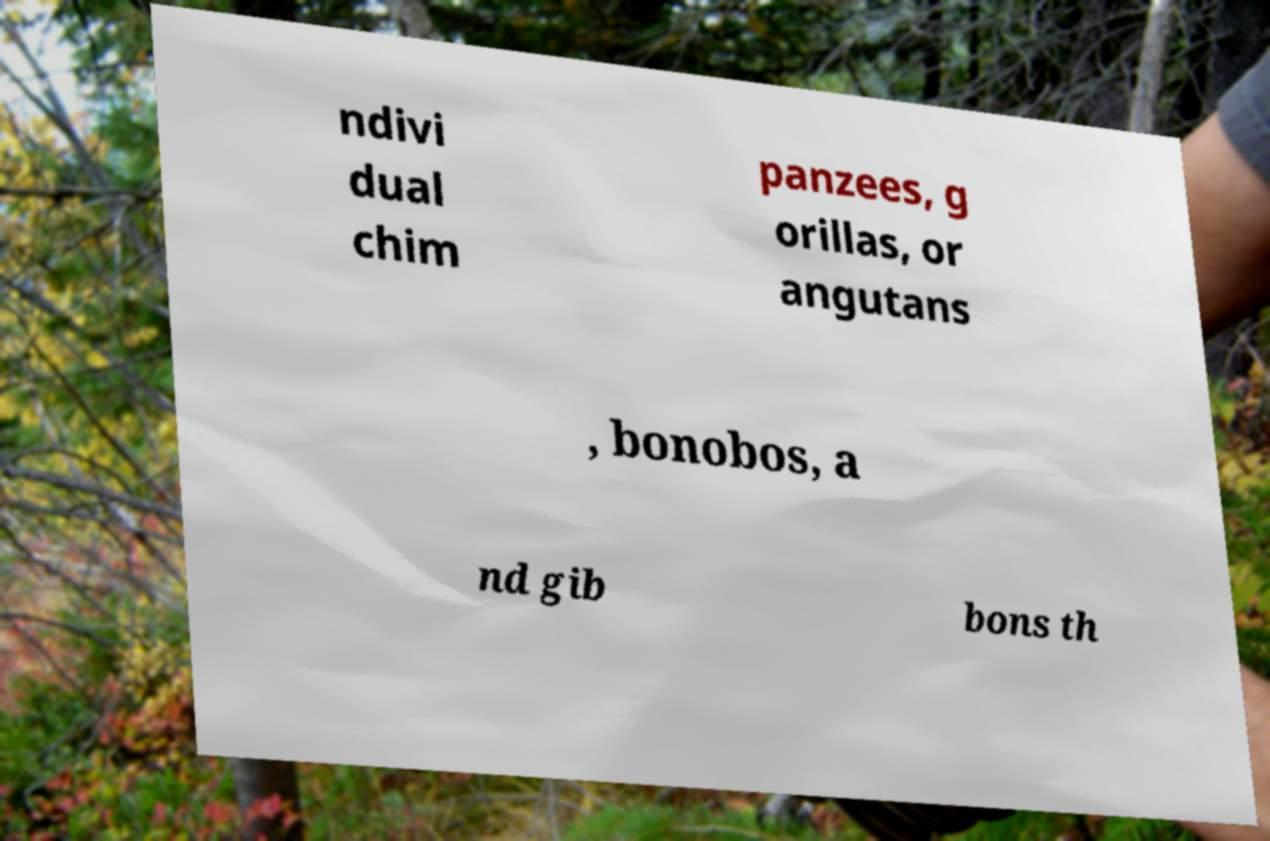Could you extract and type out the text from this image? ndivi dual chim panzees, g orillas, or angutans , bonobos, a nd gib bons th 